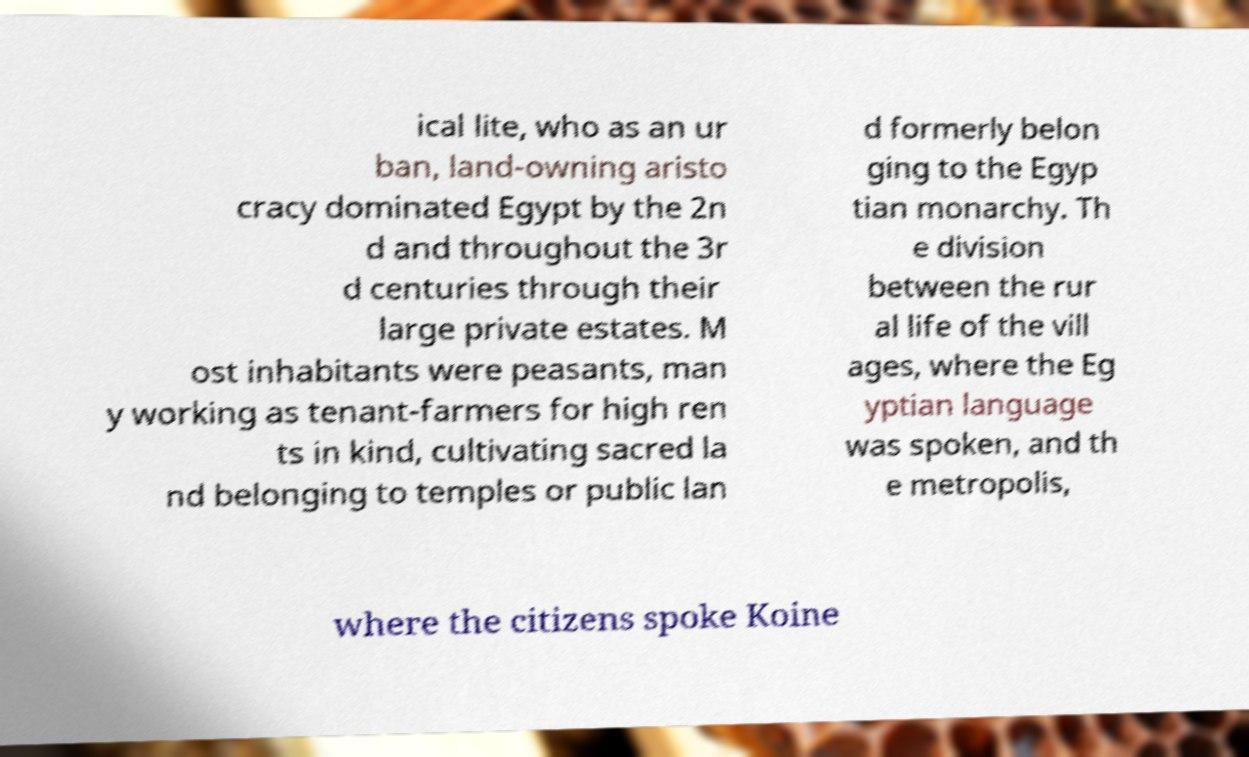Could you extract and type out the text from this image? ical lite, who as an ur ban, land-owning aristo cracy dominated Egypt by the 2n d and throughout the 3r d centuries through their large private estates. M ost inhabitants were peasants, man y working as tenant-farmers for high ren ts in kind, cultivating sacred la nd belonging to temples or public lan d formerly belon ging to the Egyp tian monarchy. Th e division between the rur al life of the vill ages, where the Eg yptian language was spoken, and th e metropolis, where the citizens spoke Koine 